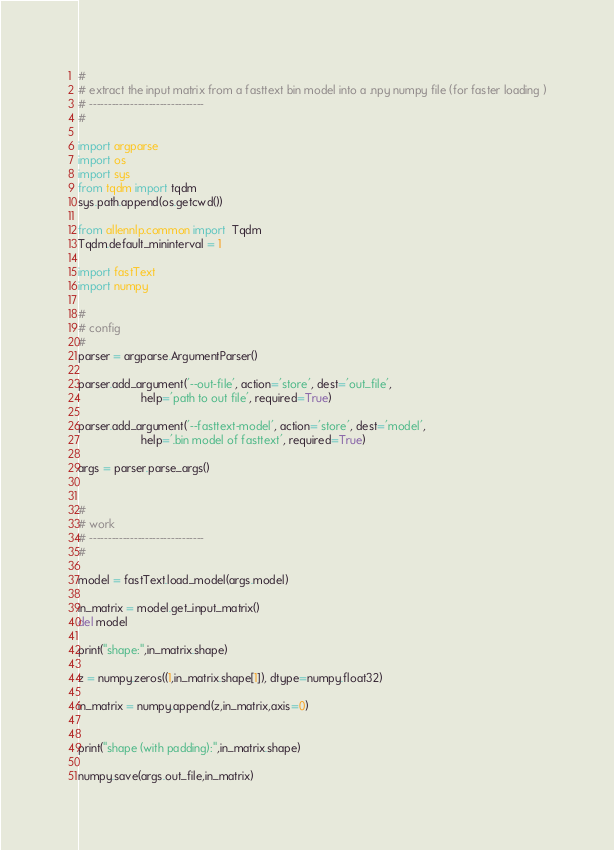Convert code to text. <code><loc_0><loc_0><loc_500><loc_500><_Python_>#
# extract the input matrix from a fasttext bin model into a .npy numpy file (for faster loading )
# -------------------------------
#

import argparse
import os
import sys
from tqdm import tqdm
sys.path.append(os.getcwd())

from allennlp.common import  Tqdm
Tqdm.default_mininterval = 1

import fastText
import numpy

#
# config
#
parser = argparse.ArgumentParser()

parser.add_argument('--out-file', action='store', dest='out_file',
                    help='path to out file', required=True)

parser.add_argument('--fasttext-model', action='store', dest='model',
                    help='.bin model of fasttext', required=True)

args = parser.parse_args()


#
# work
# -------------------------------
# 
    
model = fastText.load_model(args.model)

in_matrix = model.get_input_matrix()
del model

print("shape:",in_matrix.shape)

z = numpy.zeros((1,in_matrix.shape[1]), dtype=numpy.float32)

in_matrix = numpy.append(z,in_matrix,axis=0)


print("shape (with padding):",in_matrix.shape)

numpy.save(args.out_file,in_matrix)
</code> 